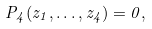Convert formula to latex. <formula><loc_0><loc_0><loc_500><loc_500>P _ { 4 } ( z _ { 1 } , \dots , z _ { 4 } ) = 0 ,</formula> 